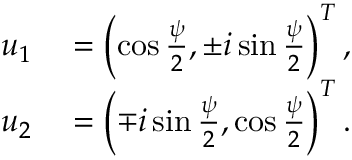<formula> <loc_0><loc_0><loc_500><loc_500>\begin{array} { r l } { u _ { 1 } } & = \left ( \cos \frac { \psi } { 2 } , \pm i \sin \frac { \psi } { 2 } \right ) ^ { T } , } \\ { u _ { 2 } } & = \left ( \mp i \sin \frac { \psi } { 2 } , \cos \frac { \psi } { 2 } \right ) ^ { T } . } \end{array}</formula> 